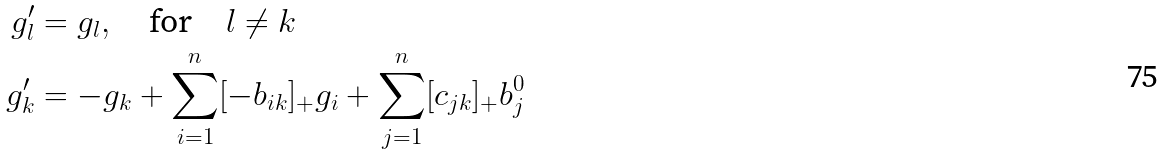<formula> <loc_0><loc_0><loc_500><loc_500>g _ { l } ^ { \prime } & = g _ { l } , \quad \text {for} \quad l \neq k \\ g _ { k } ^ { \prime } & = - g _ { k } + \sum _ { i = 1 } ^ { n } [ - b _ { i k } ] _ { + } g _ { i } + \sum _ { j = 1 } ^ { n } [ c _ { j k } ] _ { + } b _ { j } ^ { 0 }</formula> 